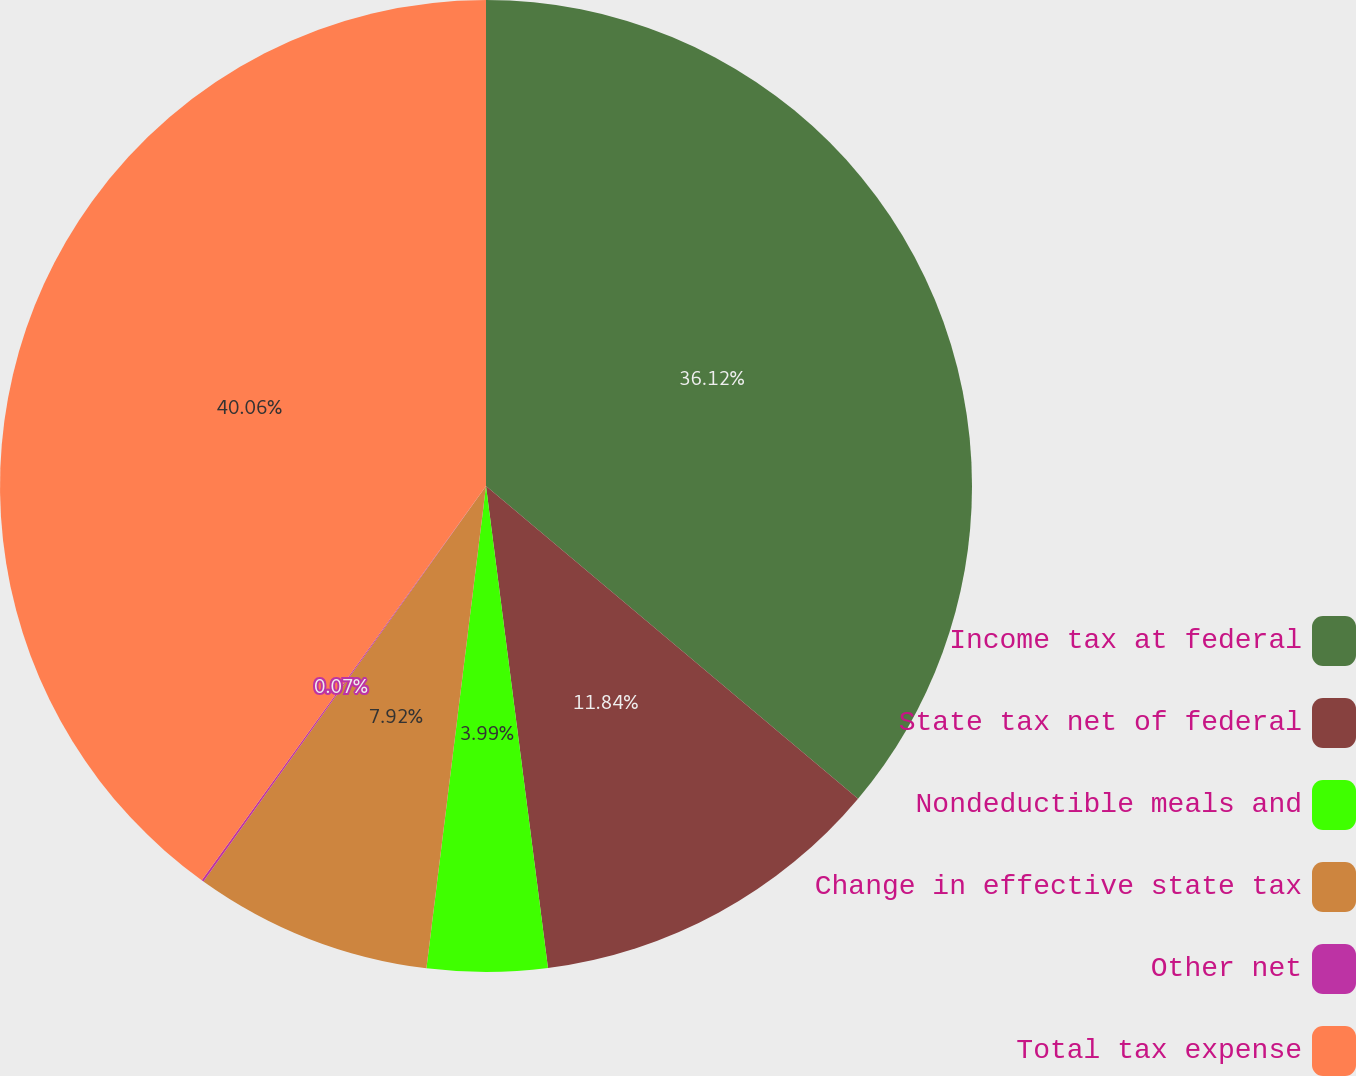Convert chart. <chart><loc_0><loc_0><loc_500><loc_500><pie_chart><fcel>Income tax at federal<fcel>State tax net of federal<fcel>Nondeductible meals and<fcel>Change in effective state tax<fcel>Other net<fcel>Total tax expense<nl><fcel>36.12%<fcel>11.84%<fcel>3.99%<fcel>7.92%<fcel>0.07%<fcel>40.05%<nl></chart> 